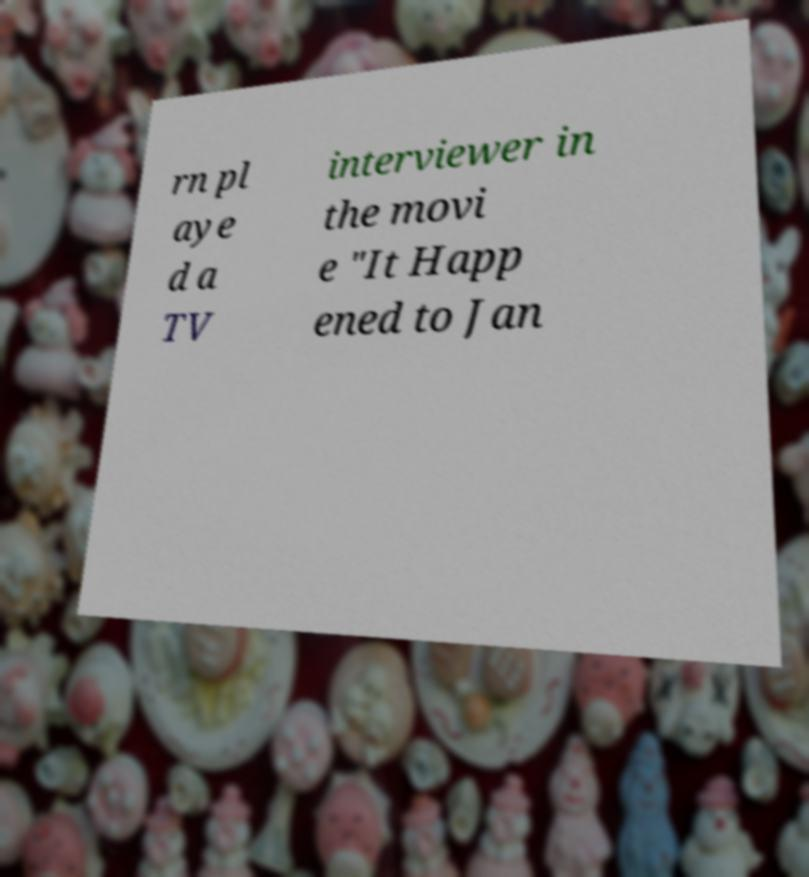Can you read and provide the text displayed in the image?This photo seems to have some interesting text. Can you extract and type it out for me? rn pl aye d a TV interviewer in the movi e "It Happ ened to Jan 